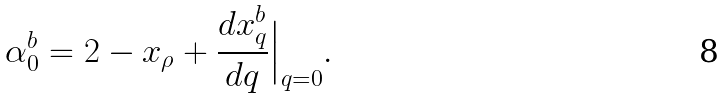Convert formula to latex. <formula><loc_0><loc_0><loc_500><loc_500>\alpha _ { 0 } ^ { b } = 2 - x _ { \rho } + \frac { d x _ { q } ^ { b } } { d q } \Big | _ { q = 0 } .</formula> 